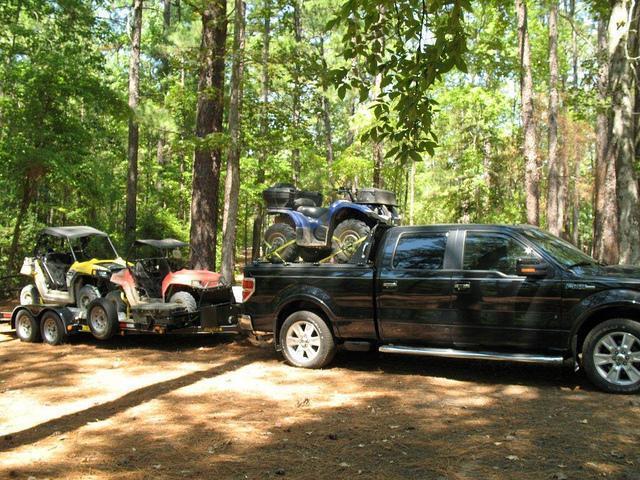How many vehicles is the truck hauling?
Give a very brief answer. 3. How many trucks are in the photo?
Give a very brief answer. 3. 